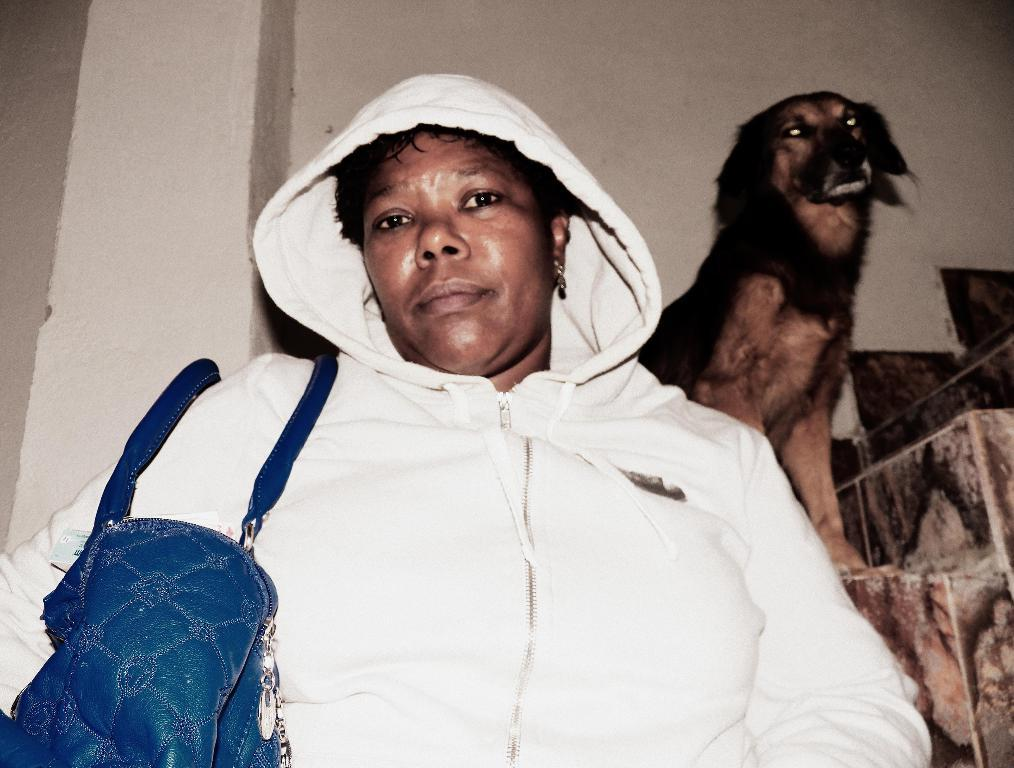What is the main subject in the image? There is a lady standing in the image. Can you describe the background of the image? There is a wall visible in the background of the image. Are there any other living beings in the image besides the lady? Yes, there is a dog standing on steps in the background of the image. What type of whip is the lady holding in the image? There is no whip present in the image. Can you describe the apparatus the dog is using to climb the steps in the image? There is no apparatus visible in the image; the dog is simply standing on the steps. 